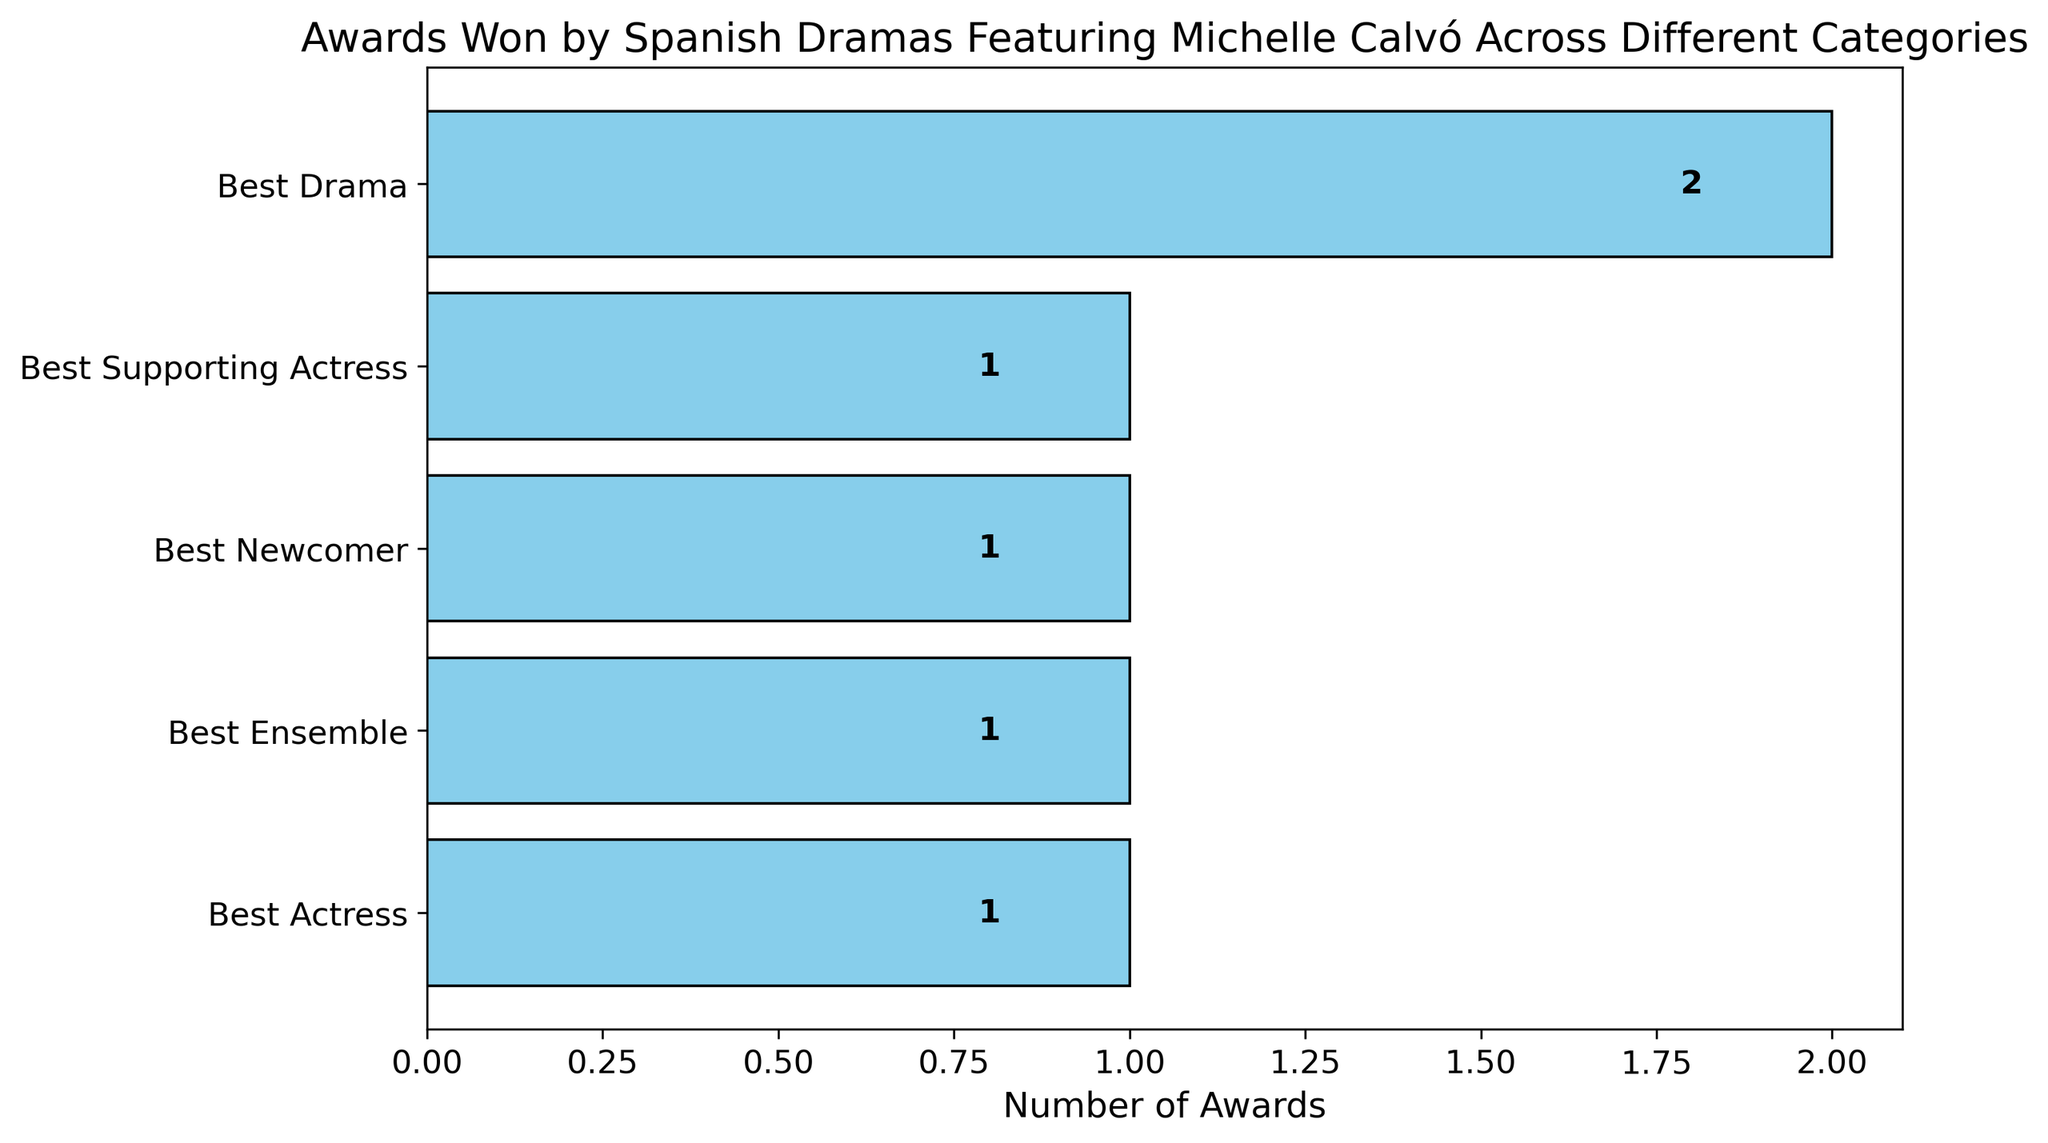How many awards has Michelle Calvó won for Best Drama? Michelle Calvó has won 2 awards for Best Drama, which is shown by the bar's label on the horizontal axis next to the "Best Drama" bar in the figure.
Answer: 2 Which category has the highest number of awards won by Michelle Calvó? The bar representing the "Best Drama" category is the longest, indicating it has the highest number of awards won by Michelle Calvó. The value next to the bar is 2.
Answer: Best Drama How many categories have exactly 1 award won by Michelle Calvó? The figure shows four bars labeled with the number "1" alongside them: Best Actress, Best Supporting Actress, Best Newcomer, and Best Ensemble.
Answer: 4 What is the sum of the awards won by Michelle Calvó in the categories of Best Actress and Best Supporting Actress? Look at the number of awards next to the bars for Best Actress (1) and Best Supporting Actress (1). Add these numbers together: 1 + 1 = 2.
Answer: 2 If a new award for Best Actress is won by Michelle Calvó, how will the total number of awards in that category compare to Best Drama? Currently, the Best Actress category has 1 award and Best Drama has 2. If Best Actress gets 1 more, it will have 2 awards, equal to Best Drama.
Answer: Equal Which categories have fewer awards than Best Drama? All categories except Best Drama have fewer awards. Specifically, Best Actress, Best Supporting Actress, Best Newcomer, and Best Ensemble each have 1 award, which is less than 2 awards in Best Drama.
Answer: Best Actress, Best Supporting Actress, Best Newcomer, Best Ensemble What is the most frequent number of awards won across all categories? The number 1 appears most frequently next to the bars for Best Actress, Best Supporting Actress, Best Newcomer, and Best Ensemble, making it the most frequent number.
Answer: 1 What's the difference in the number of awards won between Best Drama and Best Ensemble? Best Drama has 2 awards and Best Ensemble has 1 award. The difference is 2 - 1 = 1.
Answer: 1 How many total awards have been won by Michelle Calvó across all categories? Add the numbers next to all the bars: 2 (Best Drama) + 1 (Best Actress) + 1 (Best Supporting Actress) + 1 (Best Newcomer) + 1 (Best Ensemble) = 6.
Answer: 6 Which categories are represented by light blue bars in the figure? All categories have light blue bars, as the color is consistent across the figure. These categories include Best Drama, Best Actress, Best Supporting Actress, Best Newcomer, and Best Ensemble.
Answer: Best Drama, Best Actress, Best Supporting Actress, Best Newcomer, Best Ensemble 